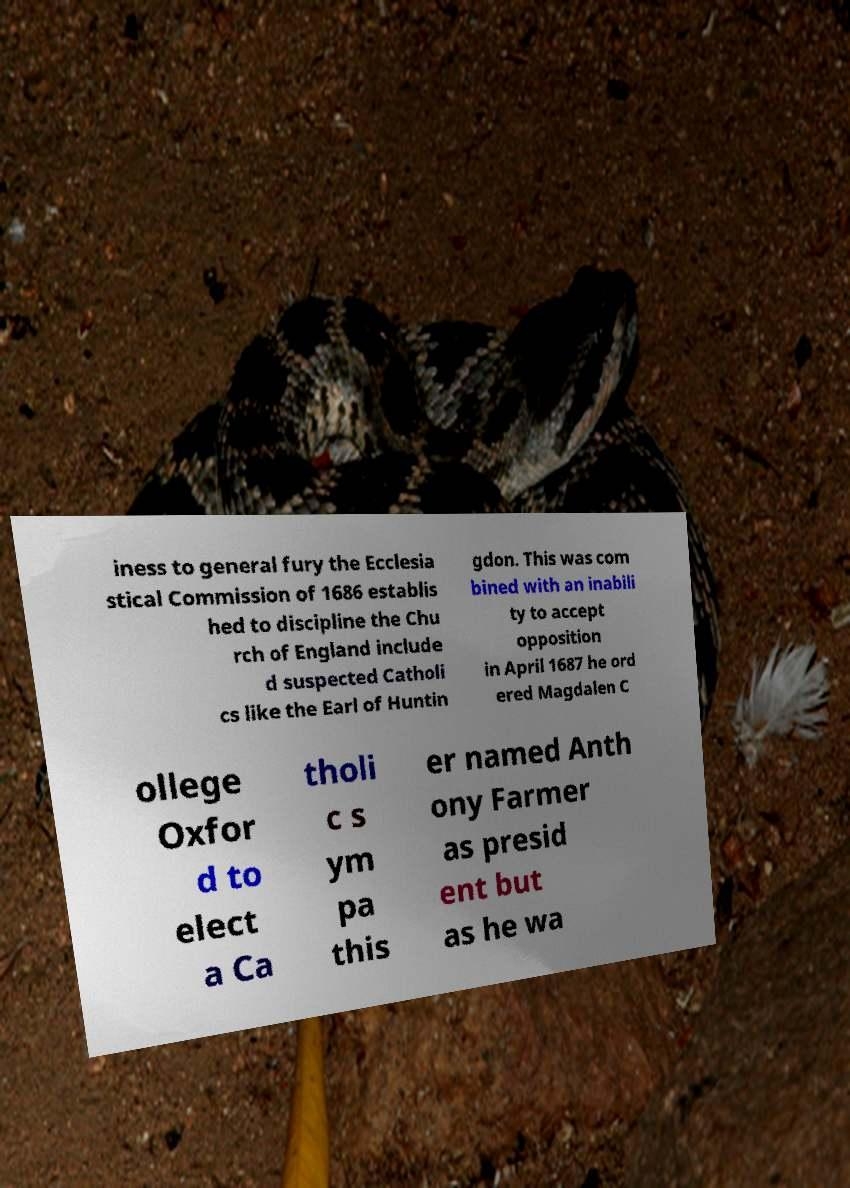Can you read and provide the text displayed in the image?This photo seems to have some interesting text. Can you extract and type it out for me? iness to general fury the Ecclesia stical Commission of 1686 establis hed to discipline the Chu rch of England include d suspected Catholi cs like the Earl of Huntin gdon. This was com bined with an inabili ty to accept opposition in April 1687 he ord ered Magdalen C ollege Oxfor d to elect a Ca tholi c s ym pa this er named Anth ony Farmer as presid ent but as he wa 